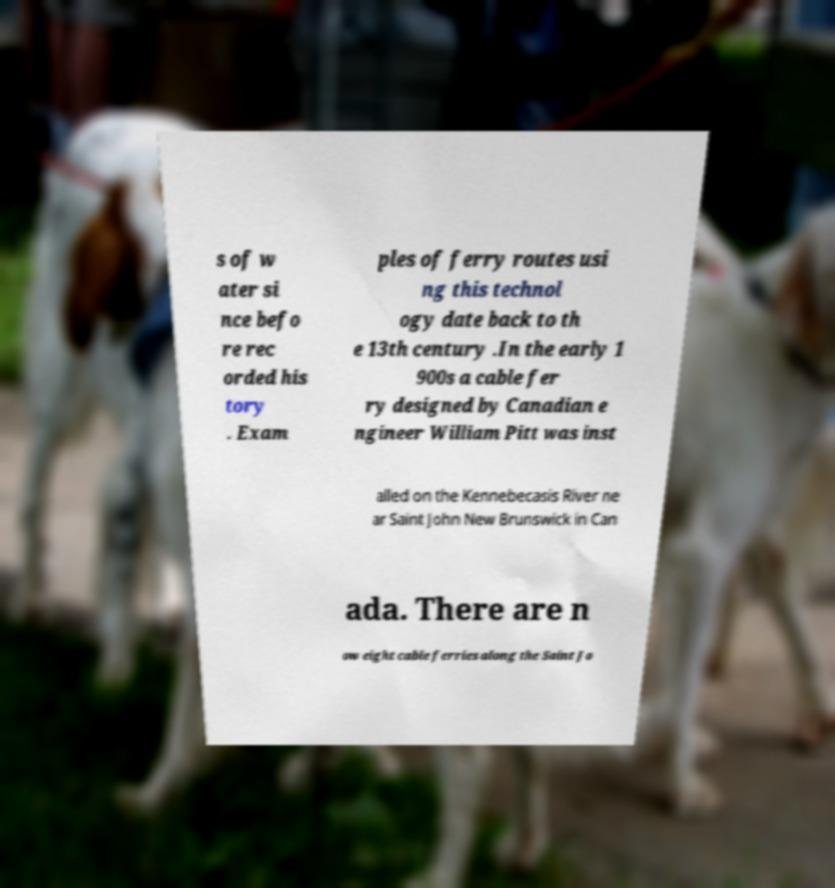Can you read and provide the text displayed in the image?This photo seems to have some interesting text. Can you extract and type it out for me? s of w ater si nce befo re rec orded his tory . Exam ples of ferry routes usi ng this technol ogy date back to th e 13th century .In the early 1 900s a cable fer ry designed by Canadian e ngineer William Pitt was inst alled on the Kennebecasis River ne ar Saint John New Brunswick in Can ada. There are n ow eight cable ferries along the Saint Jo 